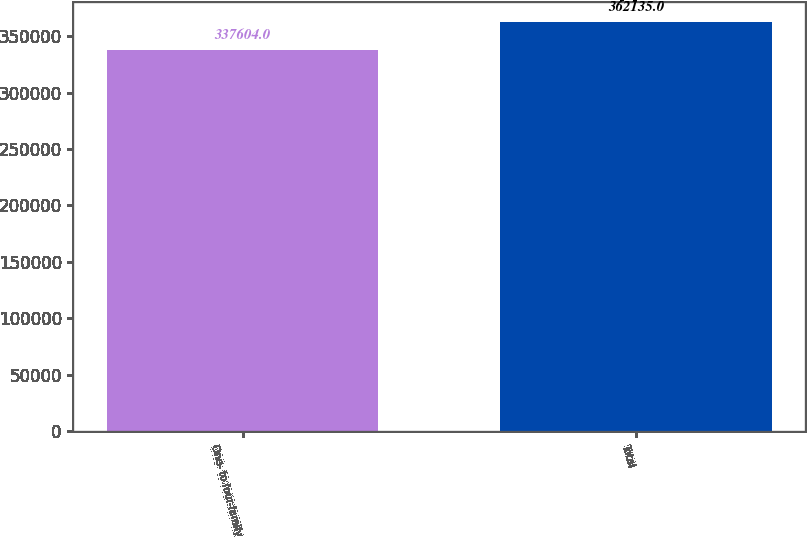Convert chart to OTSL. <chart><loc_0><loc_0><loc_500><loc_500><bar_chart><fcel>One- to four-family<fcel>Total<nl><fcel>337604<fcel>362135<nl></chart> 